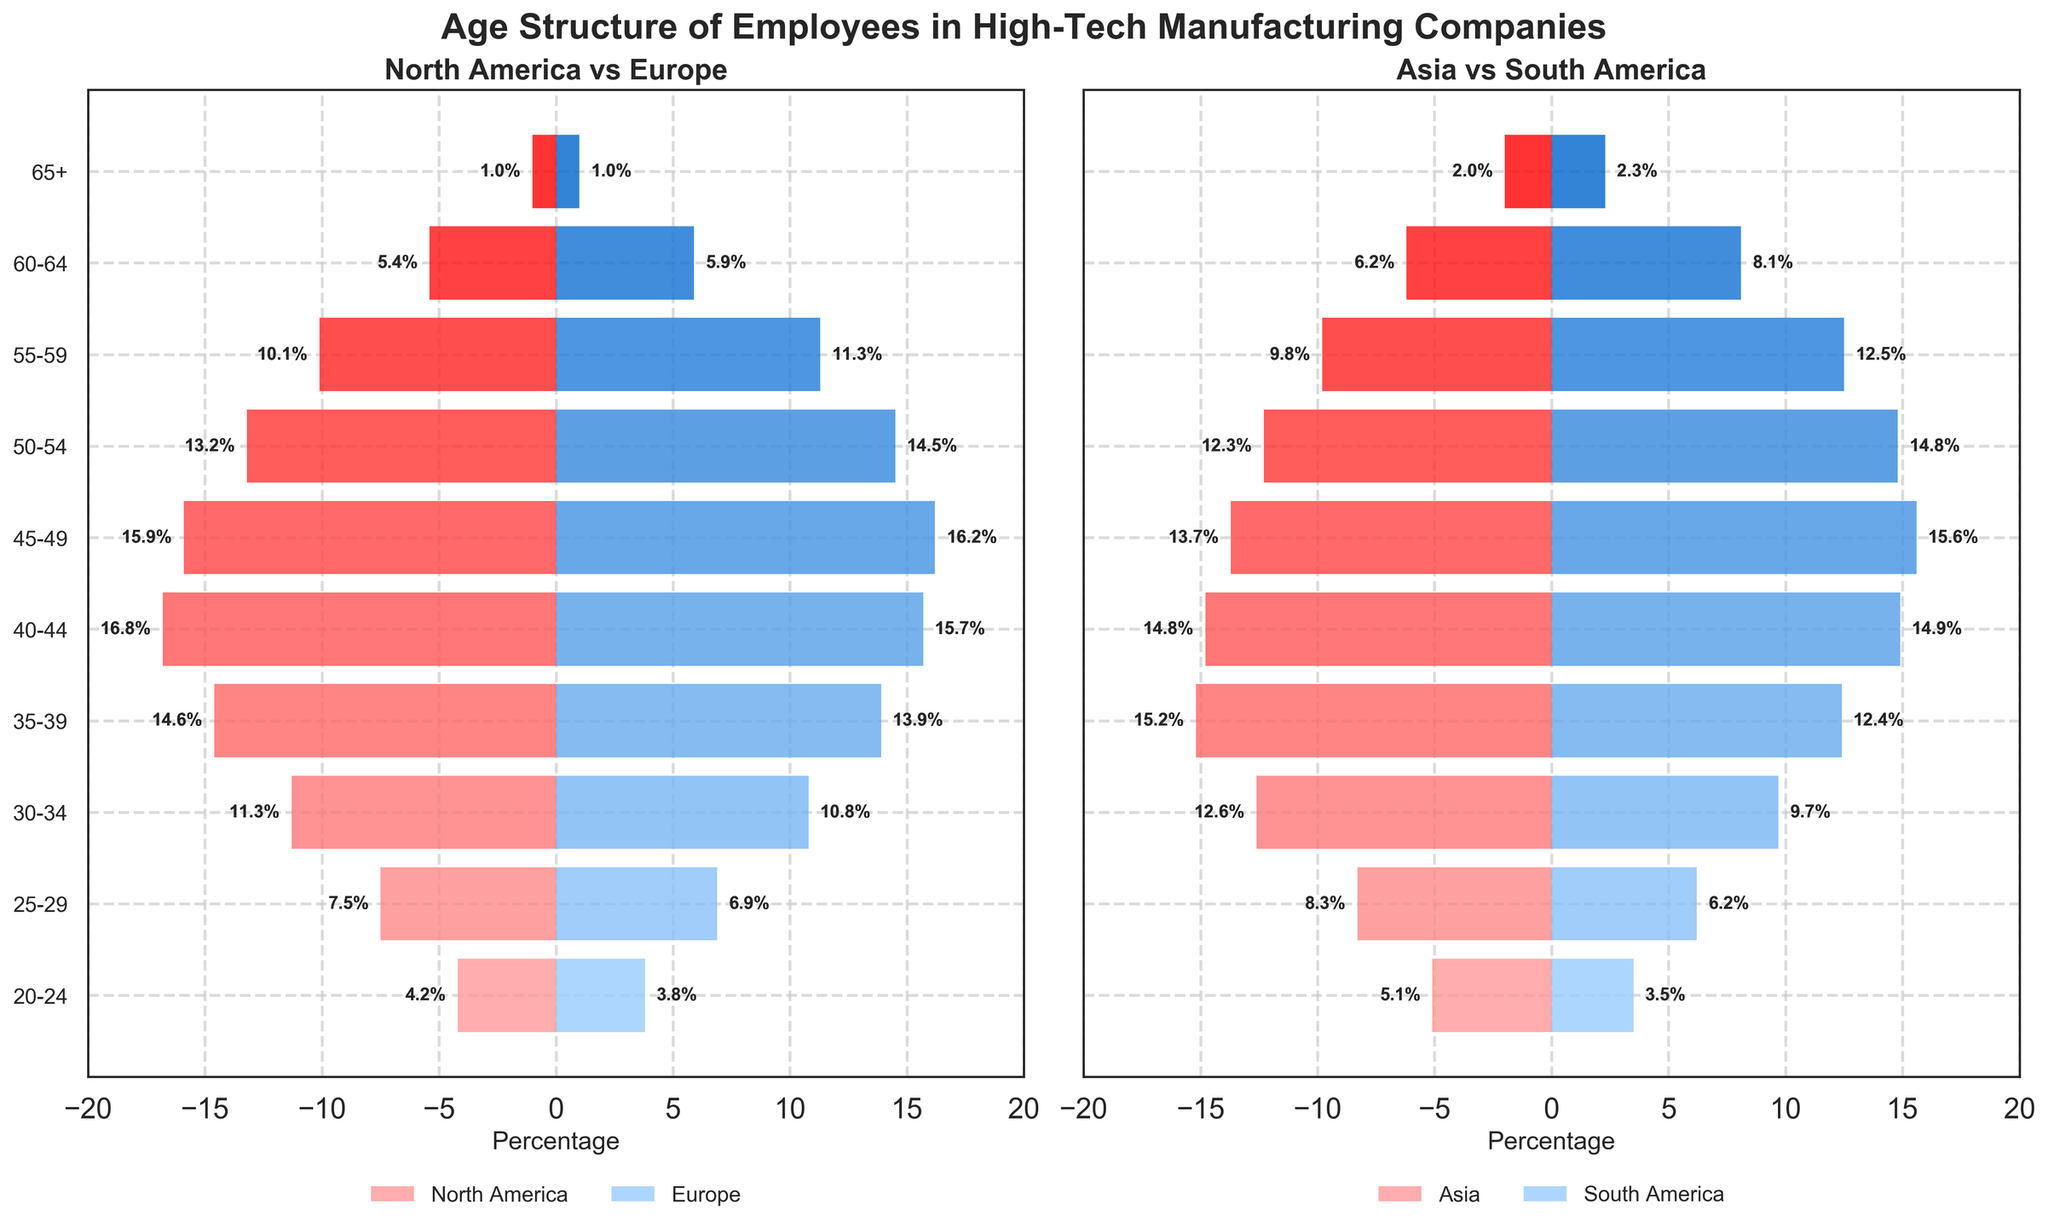What is the title of the figure? The title of the figure is displayed at the top and reads "Age Structure of Employees in High-Tech Manufacturing Companies".
Answer: Age Structure of Employees in High-Tech Manufacturing Companies Which age group has the highest percentage of employees in North America? By observing the left segment labeled "North America", the bar with the highest length corresponds to the 40-44 age group.
Answer: 40-44 Compare the percentage of employees aged 50-54 in Europe and North America. Which is higher? The bar representing Europe for the age group 50-54 is longer than the bar for North America, indicating a higher percentage in Europe.
Answer: Europe What is the combined percentage of employees aged 20-24 in Asia and South America? Add the two values: 5.1% (Asia) + 3.5% (South America) = 8.6%.
Answer: 8.6% What is the percentage difference of employees aged 30-34 between Asia and South America? To find the difference, subtract South America's percentage from Asia's: 12.6% - 9.7% = 2.9%.
Answer: 2.9% Which continent has the smallest percentage of employees aged 65+? By comparing all segments for the 65+ age group, North America and Europe both show the lowest percentage of 1.0%.
Answer: North America and Europe What percentage of employees aged 40-44 are in South America compared to Asia? In South America, the percentage is 14.9% and in Asia, it is 14.8%. South America has a slightly higher percentage.
Answer: South America How do the percentages of employees aged 60-64 in Europe and Asia compare? The percentage in Europe (5.9%) is lower than in Asia (6.2%).
Answer: Asia What is the total percentage of employees aged 55-59 across all continents? Sum the percentages for all continents: 10.1% (North America) + 11.3% (Europe) + 9.8% (Asia) + 12.5% (South America) = 43.7%.
Answer: 43.7% How is the age group distribution of high-tech manufacturing employees structured differently between North America and Asia? North America has higher percentages in the older age groups (40-44, 45-49, 50-54) compared to Asia, which has higher percentages in the younger age groups (20-24, 25-29, 30-34, 35-39).
Answer: Older age groups dominate in North America, while younger age groups dominate in Asia 